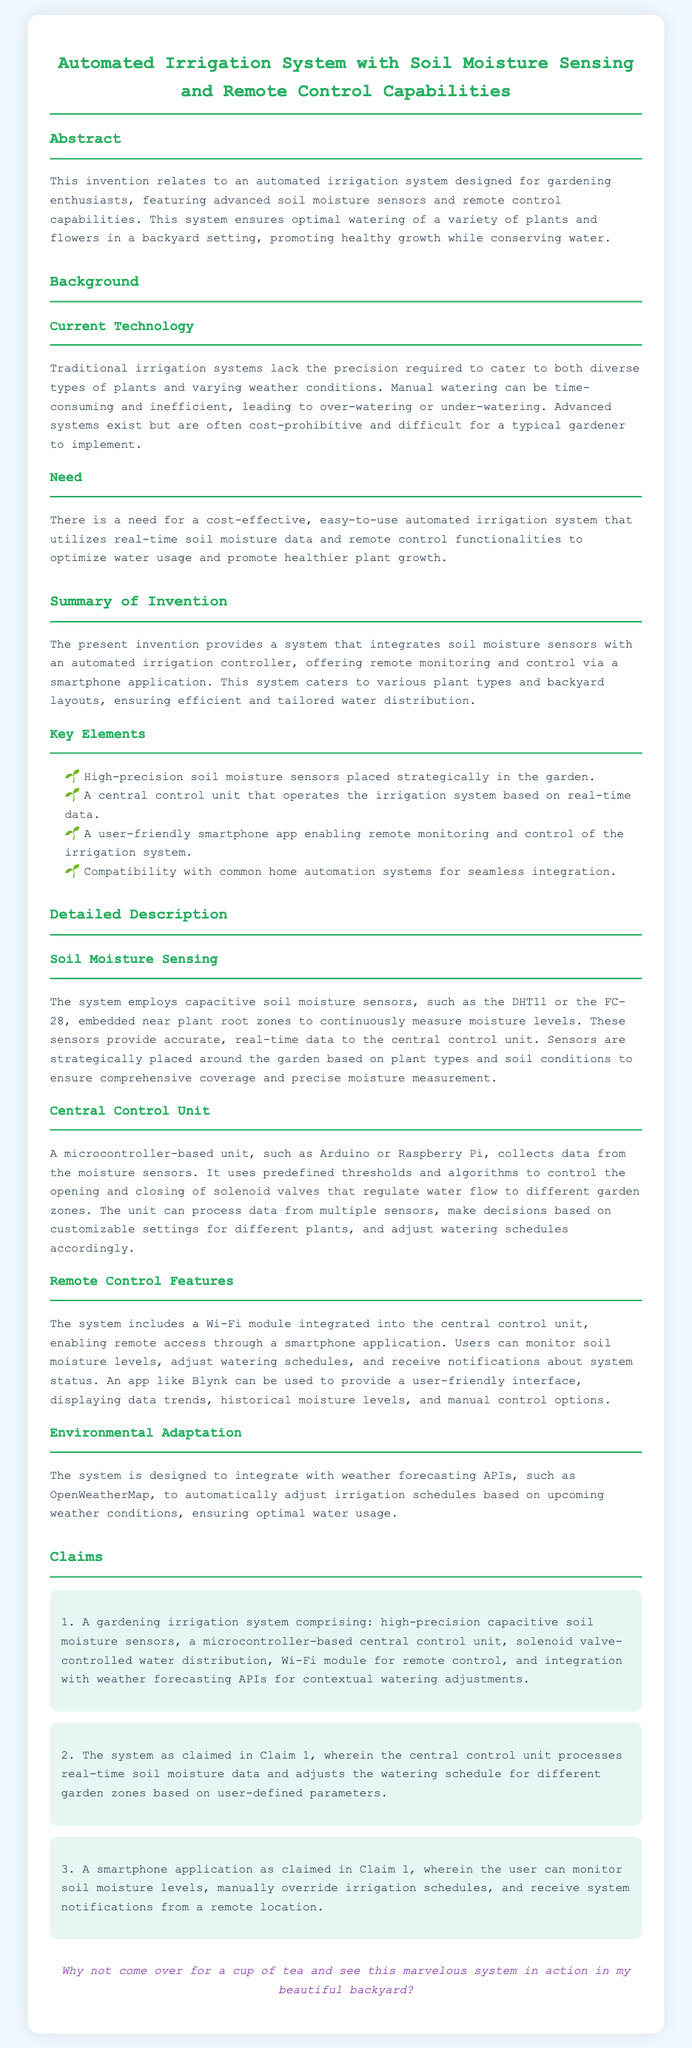What is the title of the patent application? The title of the patent application is mentioned at the top of the document.
Answer: Automated Irrigation System with Soil Moisture Sensing and Remote Control Capabilities What type of sensors does the system use? The sensors used in the system for measuring soil moisture levels are specified in the detailed description section.
Answer: Capacitive soil moisture sensors What microcontroller platforms are mentioned in the document? The document lists microcontroller-based units that can be used in the central control unit.
Answer: Arduino or Raspberry Pi How does the system adapt to weather conditions? The adaptation to weather conditions is explained in the section describing environmental adaptation.
Answer: Integrates with weather forecasting APIs What can users do with the smartphone application? The functionalities of the smartphone application are discussed in the claims section, highlighting user interaction.
Answer: Monitor soil moisture levels How many claims are there in the patent application? The number of claims is indicated in the claims section of the document.
Answer: Three claims What is the primary benefit of the automated irrigation system? The benefits of the system are outlined in the abstract, emphasizing its advantages for gardeners.
Answer: Promoting healthy growth while conserving water What is the function of the solenoid valves? The role of the solenoid valves within the irrigation system is described in the detailed description.
Answer: Regulate water flow What is the purpose of the central control unit? The central control unit’s purpose is defined in the detailed description, clarifying its function in the system.
Answer: Collects data from moisture sensors 